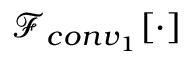<formula> <loc_0><loc_0><loc_500><loc_500>\ m a t h s c r { F } _ { c o n v _ { 1 } } [ \cdot ]</formula> 